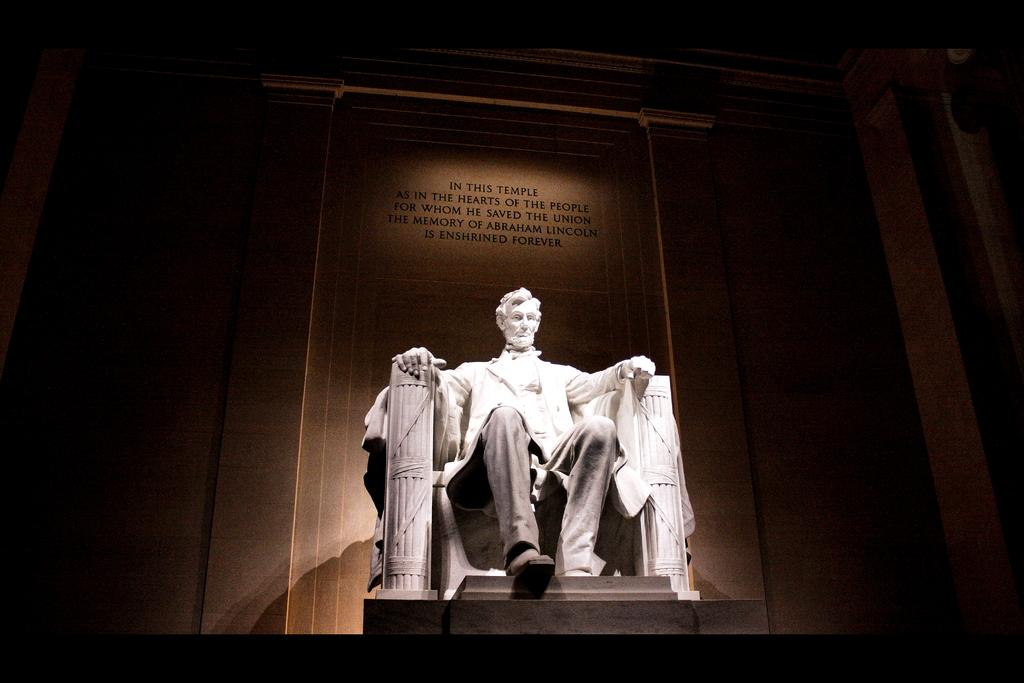What is the main subject of the image? There is a sculpture of a person in the image. How is the person depicted in the sculpture? The person is in a sitting position. What can be seen on the wall behind the sculpture? There is a quotation mentioned on the wall behind the sculpture. Can you tell me how many cords are connected to the sculpture in the image? There are no cords connected to the sculpture in the image. What type of assistance does the person in the sculpture need in the image? The person in the sculpture is a static sculpture and does not require any assistance. 